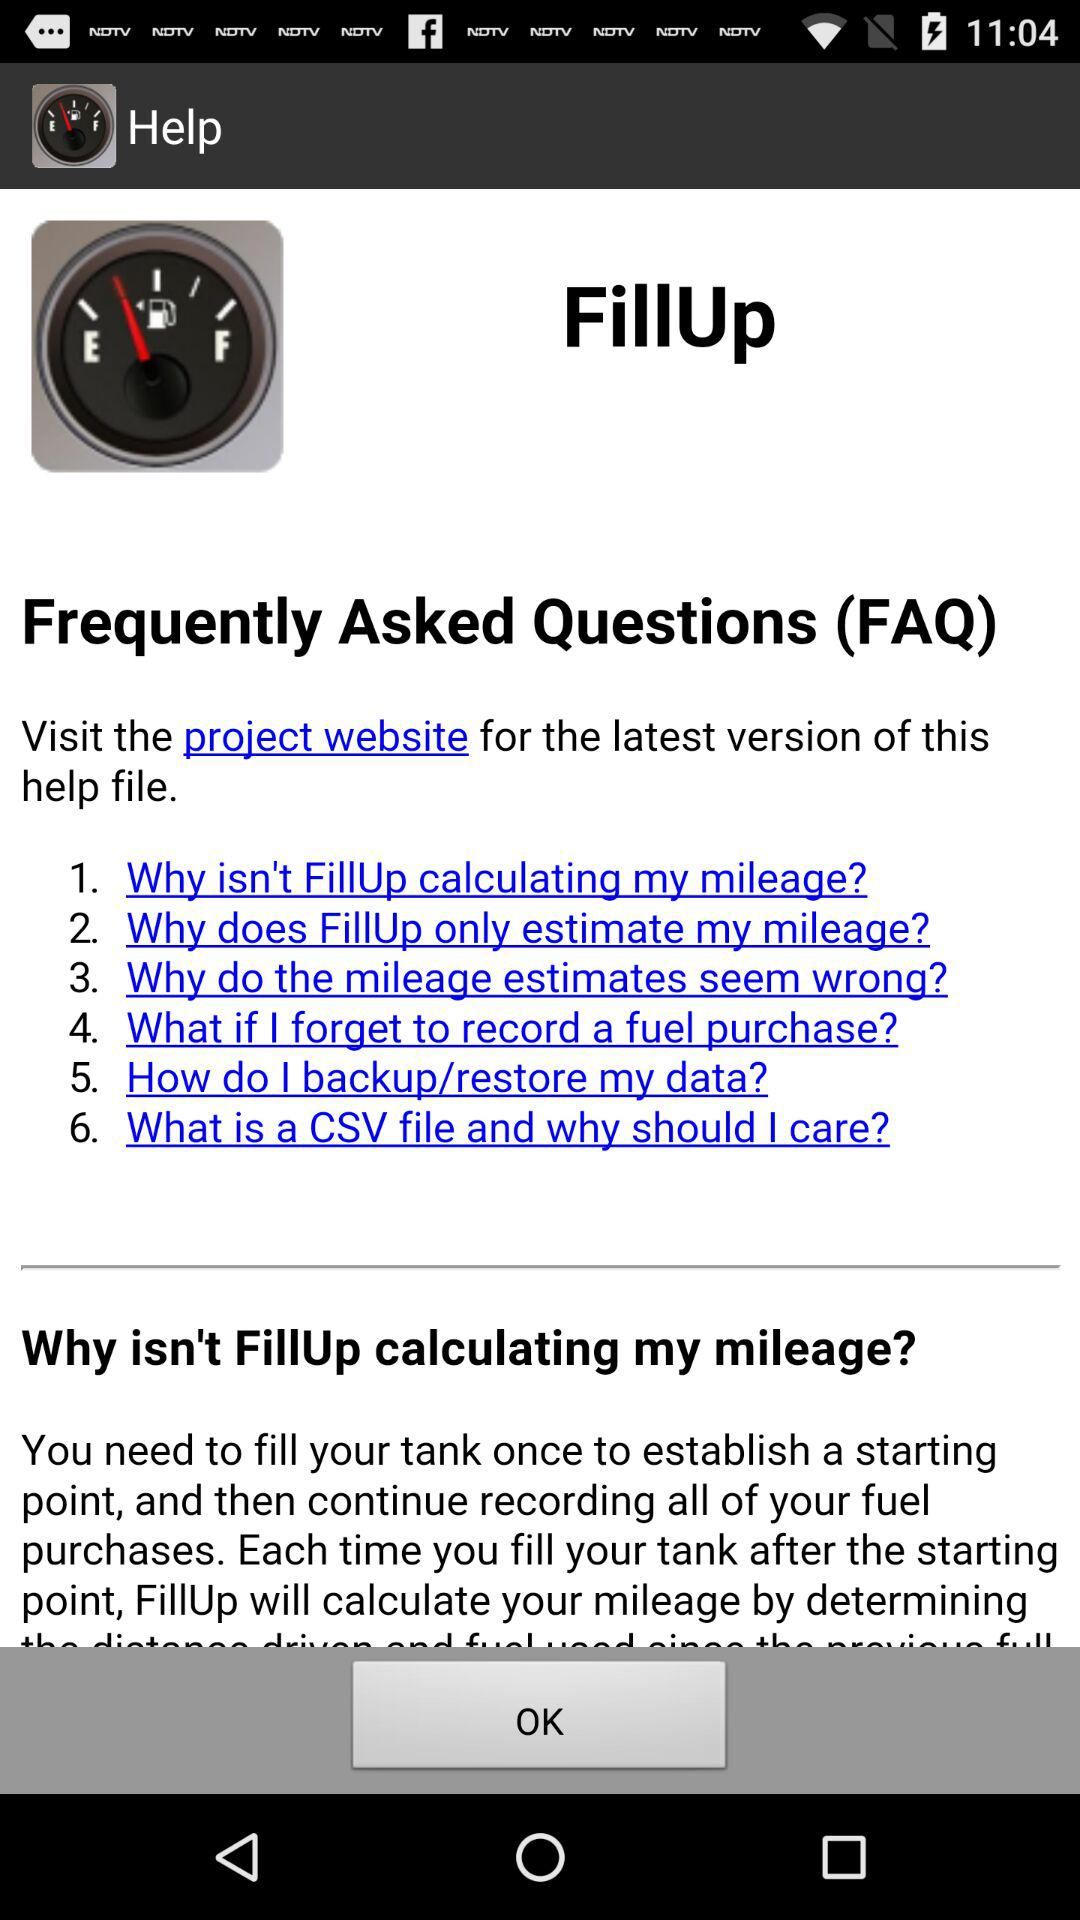What is the URL of the project website?
When the provided information is insufficient, respond with <no answer>. <no answer> 